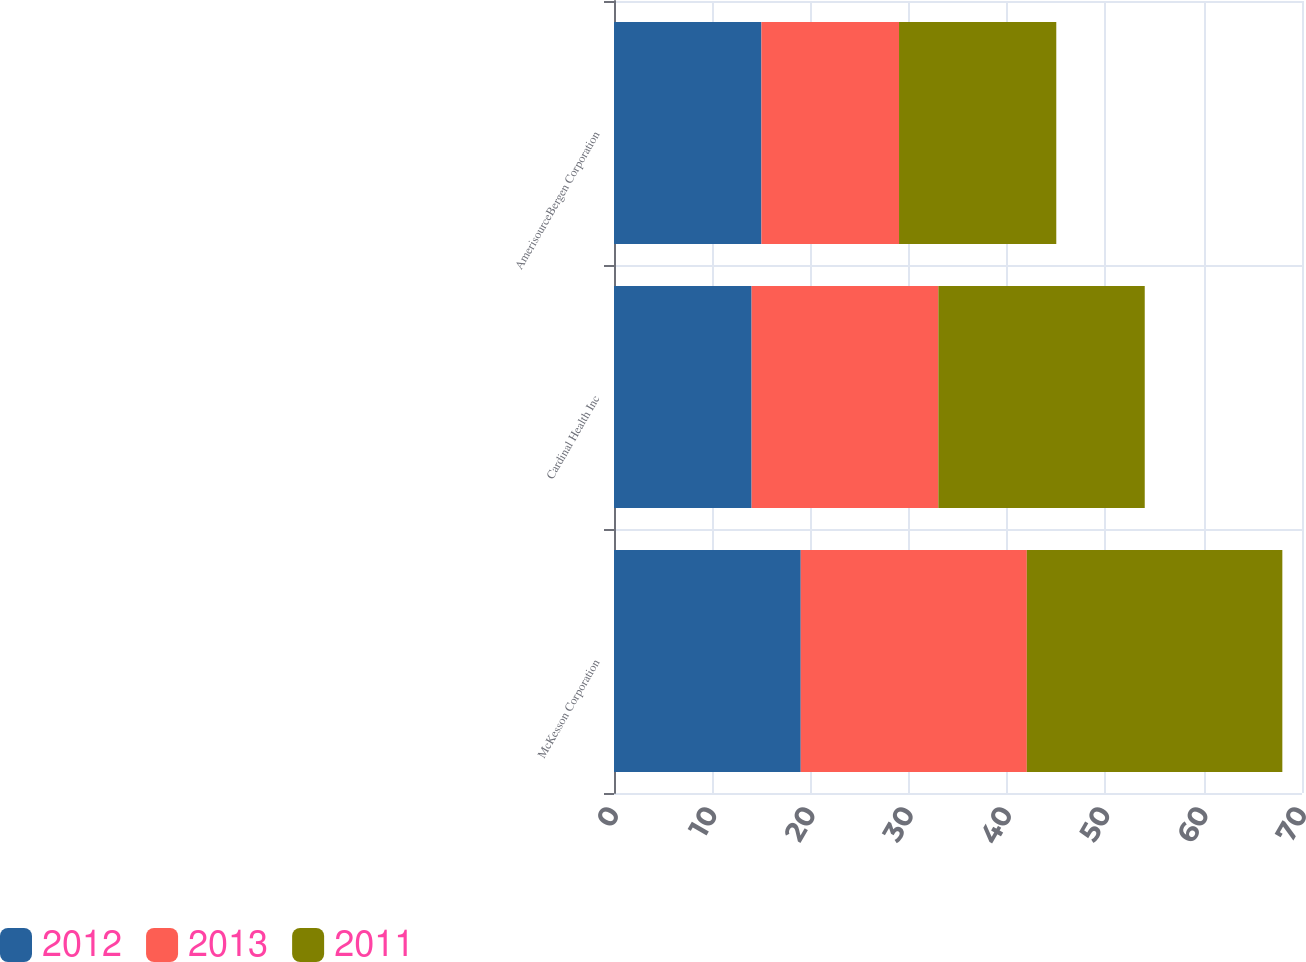Convert chart to OTSL. <chart><loc_0><loc_0><loc_500><loc_500><stacked_bar_chart><ecel><fcel>McKesson Corporation<fcel>Cardinal Health Inc<fcel>AmerisourceBergen Corporation<nl><fcel>2012<fcel>19<fcel>14<fcel>15<nl><fcel>2013<fcel>23<fcel>19<fcel>14<nl><fcel>2011<fcel>26<fcel>21<fcel>16<nl></chart> 